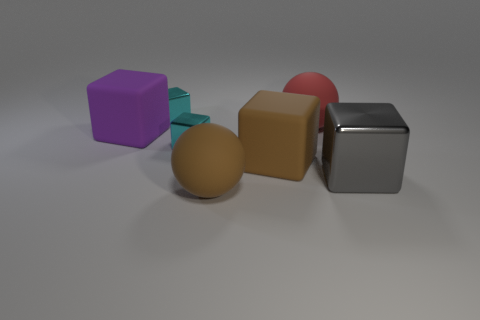How many cyan blocks must be subtracted to get 1 cyan blocks? 1 Subtract all brown matte cubes. How many cubes are left? 4 Add 1 tiny cyan cylinders. How many objects exist? 8 Subtract all purple blocks. How many blocks are left? 4 Subtract all yellow cubes. How many red spheres are left? 1 Subtract all balls. How many objects are left? 5 Subtract 1 spheres. How many spheres are left? 1 Subtract all purple spheres. Subtract all purple blocks. How many spheres are left? 2 Subtract all cyan spheres. Subtract all large objects. How many objects are left? 2 Add 1 shiny objects. How many shiny objects are left? 4 